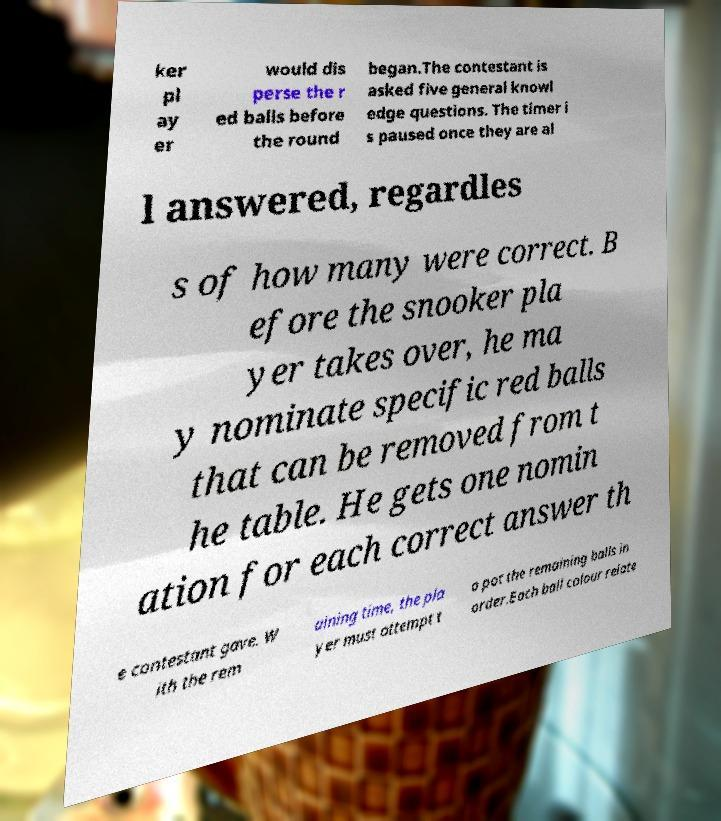I need the written content from this picture converted into text. Can you do that? ker pl ay er would dis perse the r ed balls before the round began.The contestant is asked five general knowl edge questions. The timer i s paused once they are al l answered, regardles s of how many were correct. B efore the snooker pla yer takes over, he ma y nominate specific red balls that can be removed from t he table. He gets one nomin ation for each correct answer th e contestant gave. W ith the rem aining time, the pla yer must attempt t o pot the remaining balls in order.Each ball colour relate 